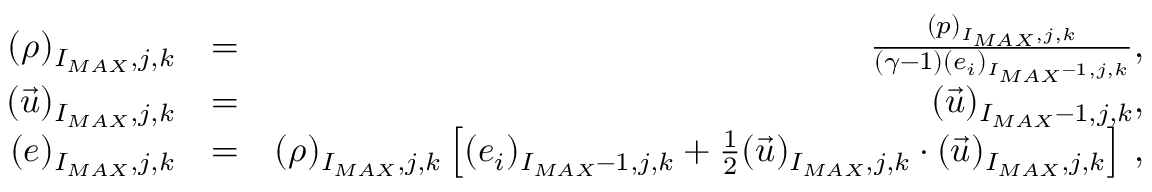<formula> <loc_0><loc_0><loc_500><loc_500>\begin{array} { r l r } { { ( \rho ) _ { I _ { M A X } , j , k } } } & { = } & { { \frac { ( p ) _ { I _ { M A X } , j , k } } { ( \gamma - 1 ) ( e _ { i } ) _ { I _ { M A X } - 1 , j , k } } , } } \\ { { ( \vec { u } ) _ { I _ { M A X } , j , k } } } & { = } & { { ( \vec { u } ) _ { I _ { M A X } - 1 , j , k } , } } \\ { { ( e ) _ { I _ { M A X } , j , k } } } & { = } & { { ( \rho ) _ { I _ { M A X } , j , k } \left [ ( e _ { i } ) _ { I _ { M A X } - 1 , j , k } + \frac { 1 } { 2 } ( \vec { u } ) _ { I _ { M A X } , j , k } \cdot ( \vec { u } ) _ { I _ { M A X } , j , k } \right ] \, , } } \end{array}</formula> 